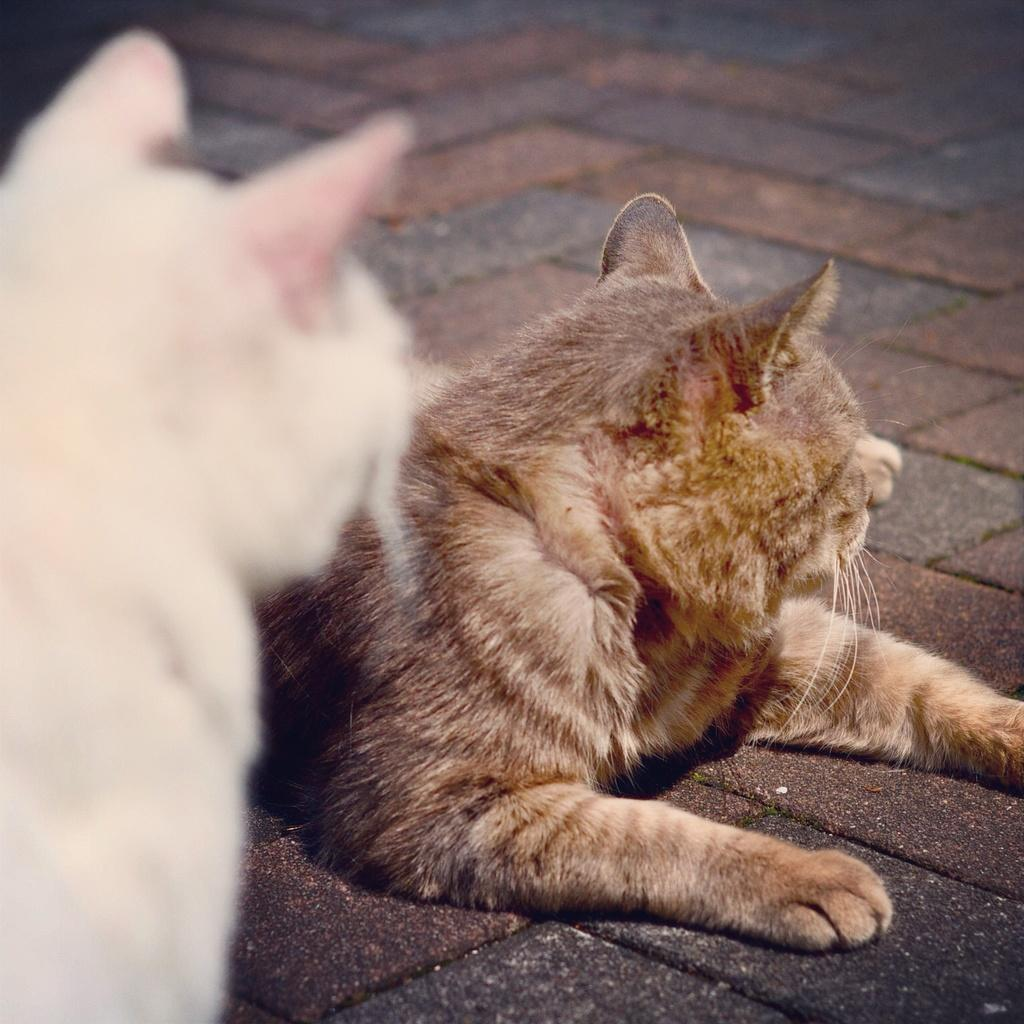How many cats are present in the image? There are two cats in the image. What are the cats doing in the image? The cats are on a surface. Is there a party happening in the image? There is no mention of a party in the image. --- Facts: 1. There is a car in the image. 2. The car is red. 3. The car has four wheels. 4. The car is parked on the street. 5. There are people walking on the sidewalk. Absurd Topics: elephant, parade Conversation: What is the main subject in the image? The main subject in the image is a car. Can you describe the car in the image? Yes, the car is red and has four wheels. Where is the car located in the image? The car is parked on the street. What else can be seen in the image? There are people walking on the sidewalk. Reasoning: Let's think step by step in order to produce the conversation. We start by identifying the main subject of the image, which is the car. Next, we describe specific features of the car, such as its color and the number of wheels. Then, we observe the location of the car, which is parked on the street. After that, we describe any other elements present in the image, which in this case are the people walking on the sidewalk. Absurd Question/Answer: Can you see an elephant participating in a parade in the image? No, there is no elephant or parade present in the image. 